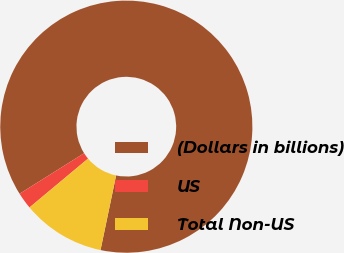Convert chart to OTSL. <chart><loc_0><loc_0><loc_500><loc_500><pie_chart><fcel>(Dollars in billions)<fcel>US<fcel>Total Non-US<nl><fcel>87.21%<fcel>2.14%<fcel>10.65%<nl></chart> 